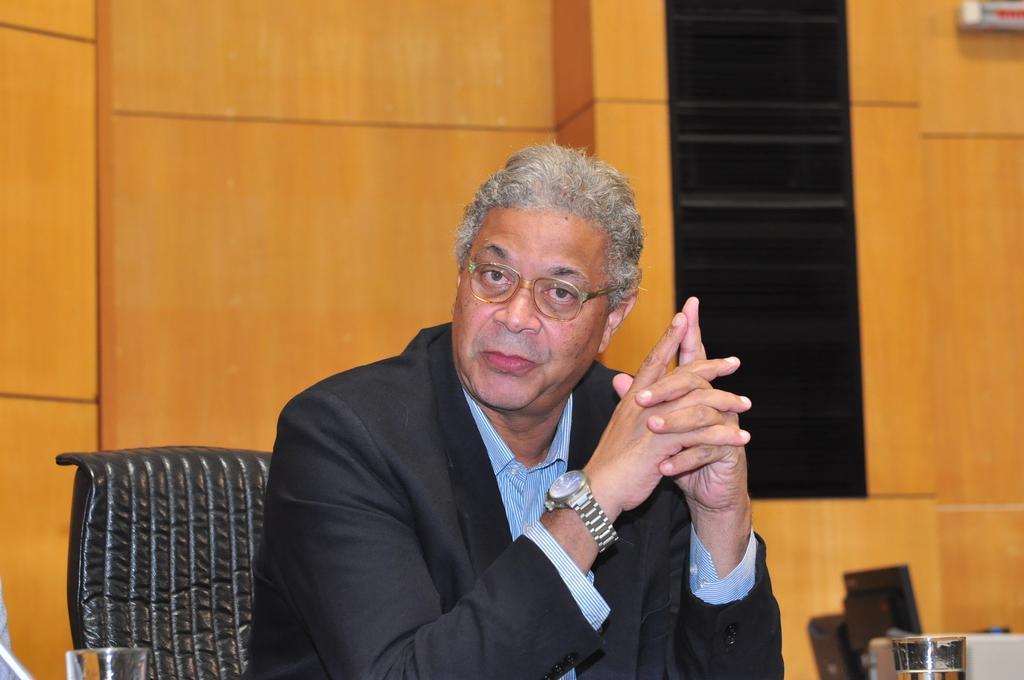How would you summarize this image in a sentence or two? In this image, we can see an old person is sitting on a chair and watching. He wore glasses and watch. At the bottom, we can see glasses and few objects. Background we can see wall. On the right side of the image, we can see black and white color objects. 